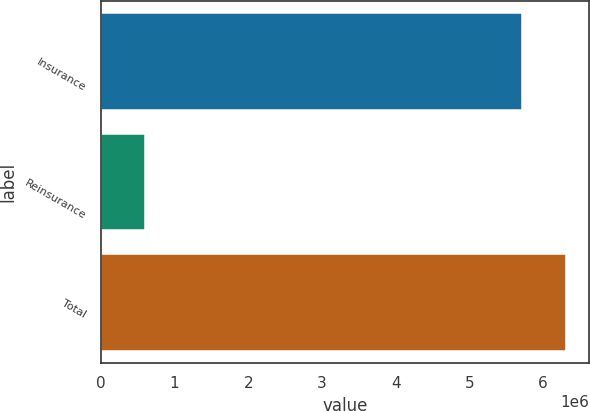<chart> <loc_0><loc_0><loc_500><loc_500><bar_chart><fcel>Insurance<fcel>Reinsurance<fcel>Total<nl><fcel>5.70644e+06<fcel>604976<fcel>6.31142e+06<nl></chart> 